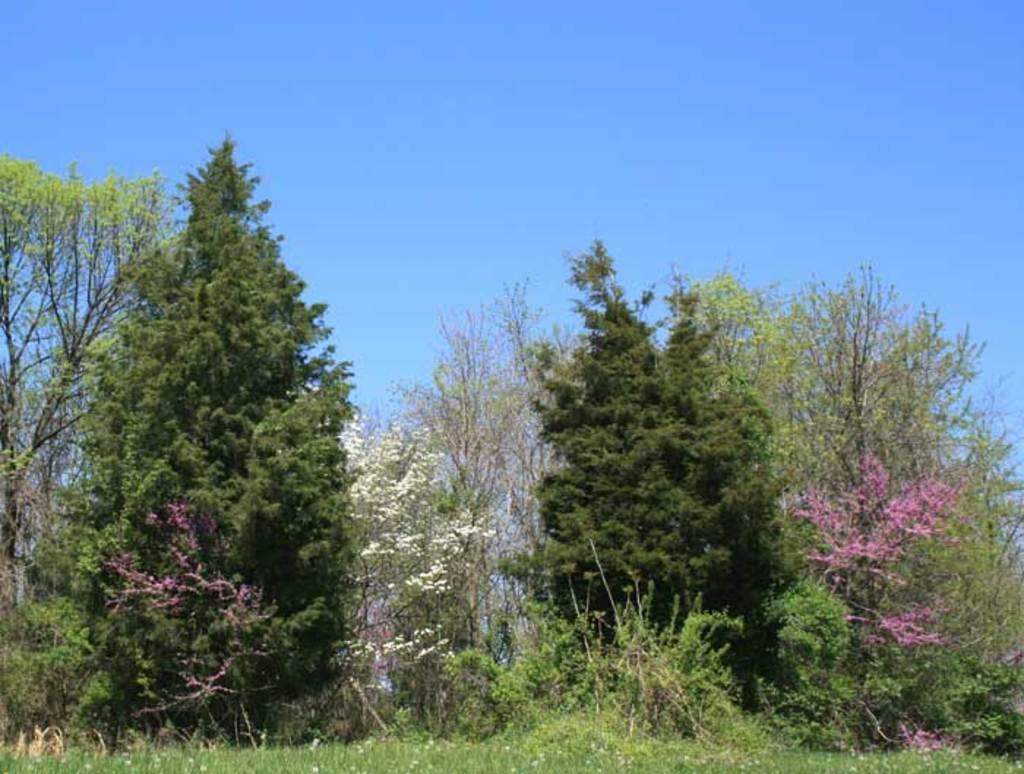What type of vegetation can be seen in the image? There are plants, flowers, and trees in the image. What is visible at the top of the image? The sky is visible at the top of the image. How many oranges are hanging from the trees in the image? There are no oranges present in the image; it features plants, flowers, and trees. What emotion can be seen on the face of the fan in the image? There is no fan present in the image, and therefore no emotion can be observed. 